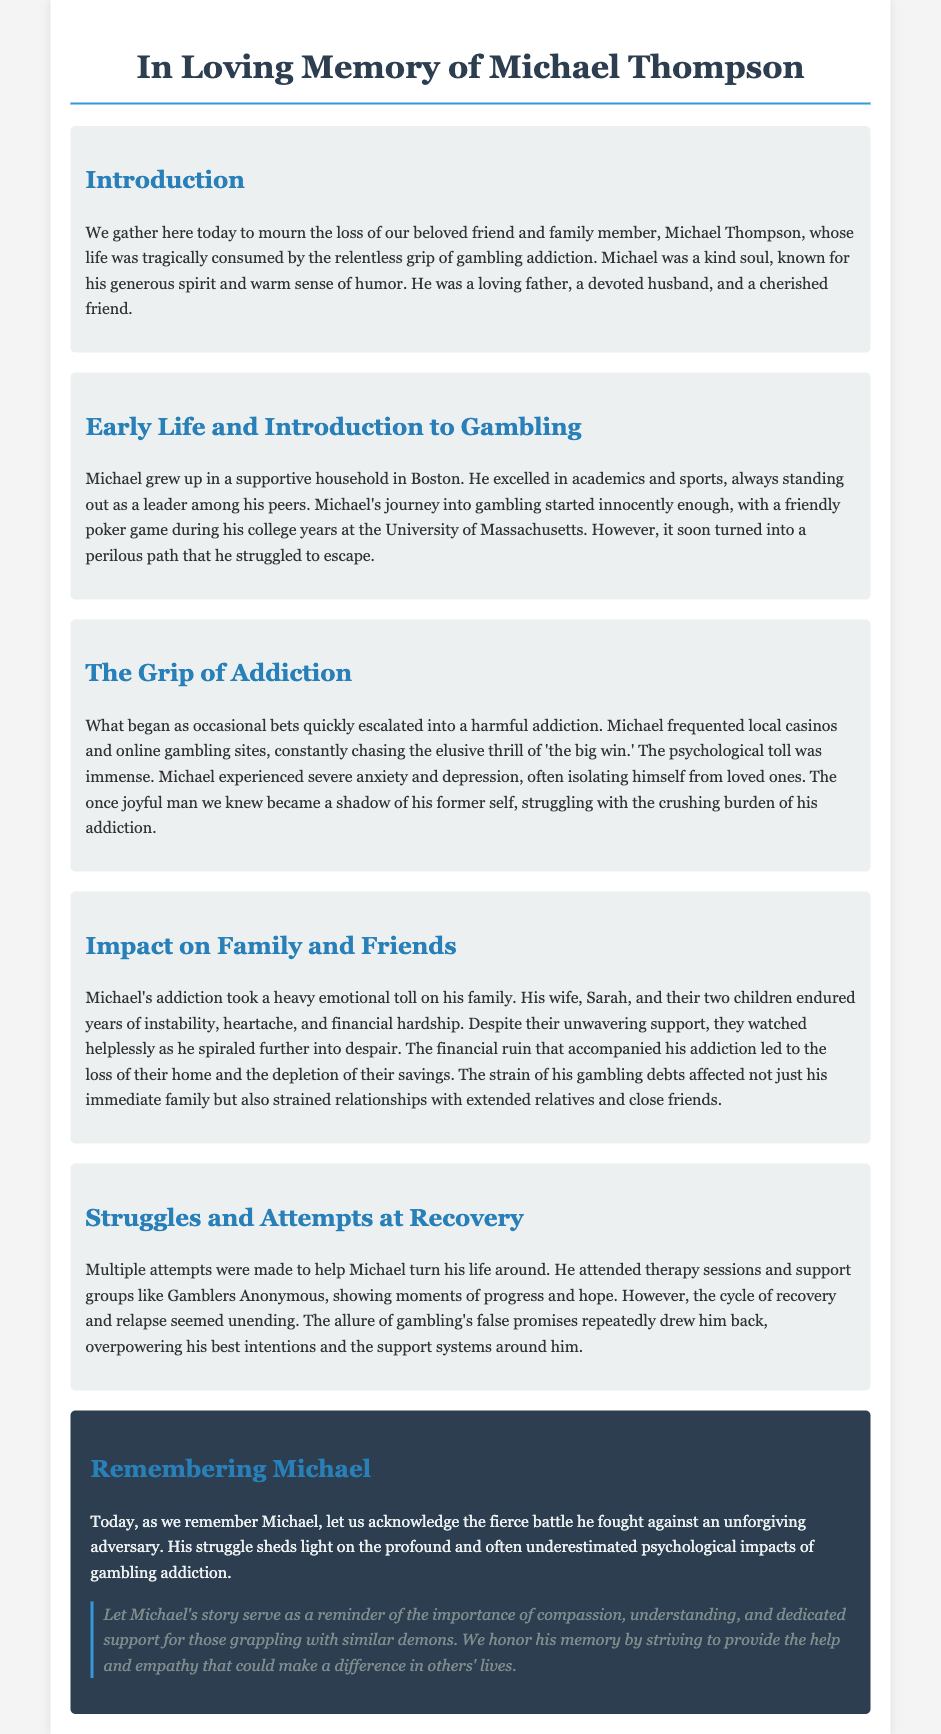what is the name of the individual being remembered? The document is a eulogy for Michael Thompson, marking his memory and life story.
Answer: Michael Thompson what was Michael's initial experience with gambling? His journey into gambling started innocently with a friendly poker game during college, indicating a casual beginning.
Answer: Friendly poker game what were the impacts of Michael's addiction on his family? The addiction caused emotional toll, financial hardship, and instability, highlighting the wide-reaching consequences affecting his loved ones.
Answer: Emotional toll and financial hardship how many children did Michael have? The document states that Michael had two children, specifying his immediate family structure.
Answer: Two children what support groups did Michael attend? The document mentions he attended therapy sessions and Gamblers Anonymous as part of his recovery efforts.
Answer: Gamblers Anonymous how did Michael's addiction affect his health? It led to severe anxiety and depression, which shows the psychological impact of his gambling addiction on his mental well-being.
Answer: Severe anxiety and depression what lesson does the eulogy suggest we take from Michael's story? The eulogy emphasizes the importance of compassion, understanding, and dedicated support for those struggling with addiction.
Answer: Compassion and understanding what was Michael's profession? The document does not explicitly mention Michael's profession, indicating a gap in specific personal details related to his work life.
Answer: Not mentioned what is the overall tone of the eulogy? The eulogy's tone is respectful and reflective, focusing on Michael's struggle and the impact of his life on those around him.
Answer: Respectful and reflective 